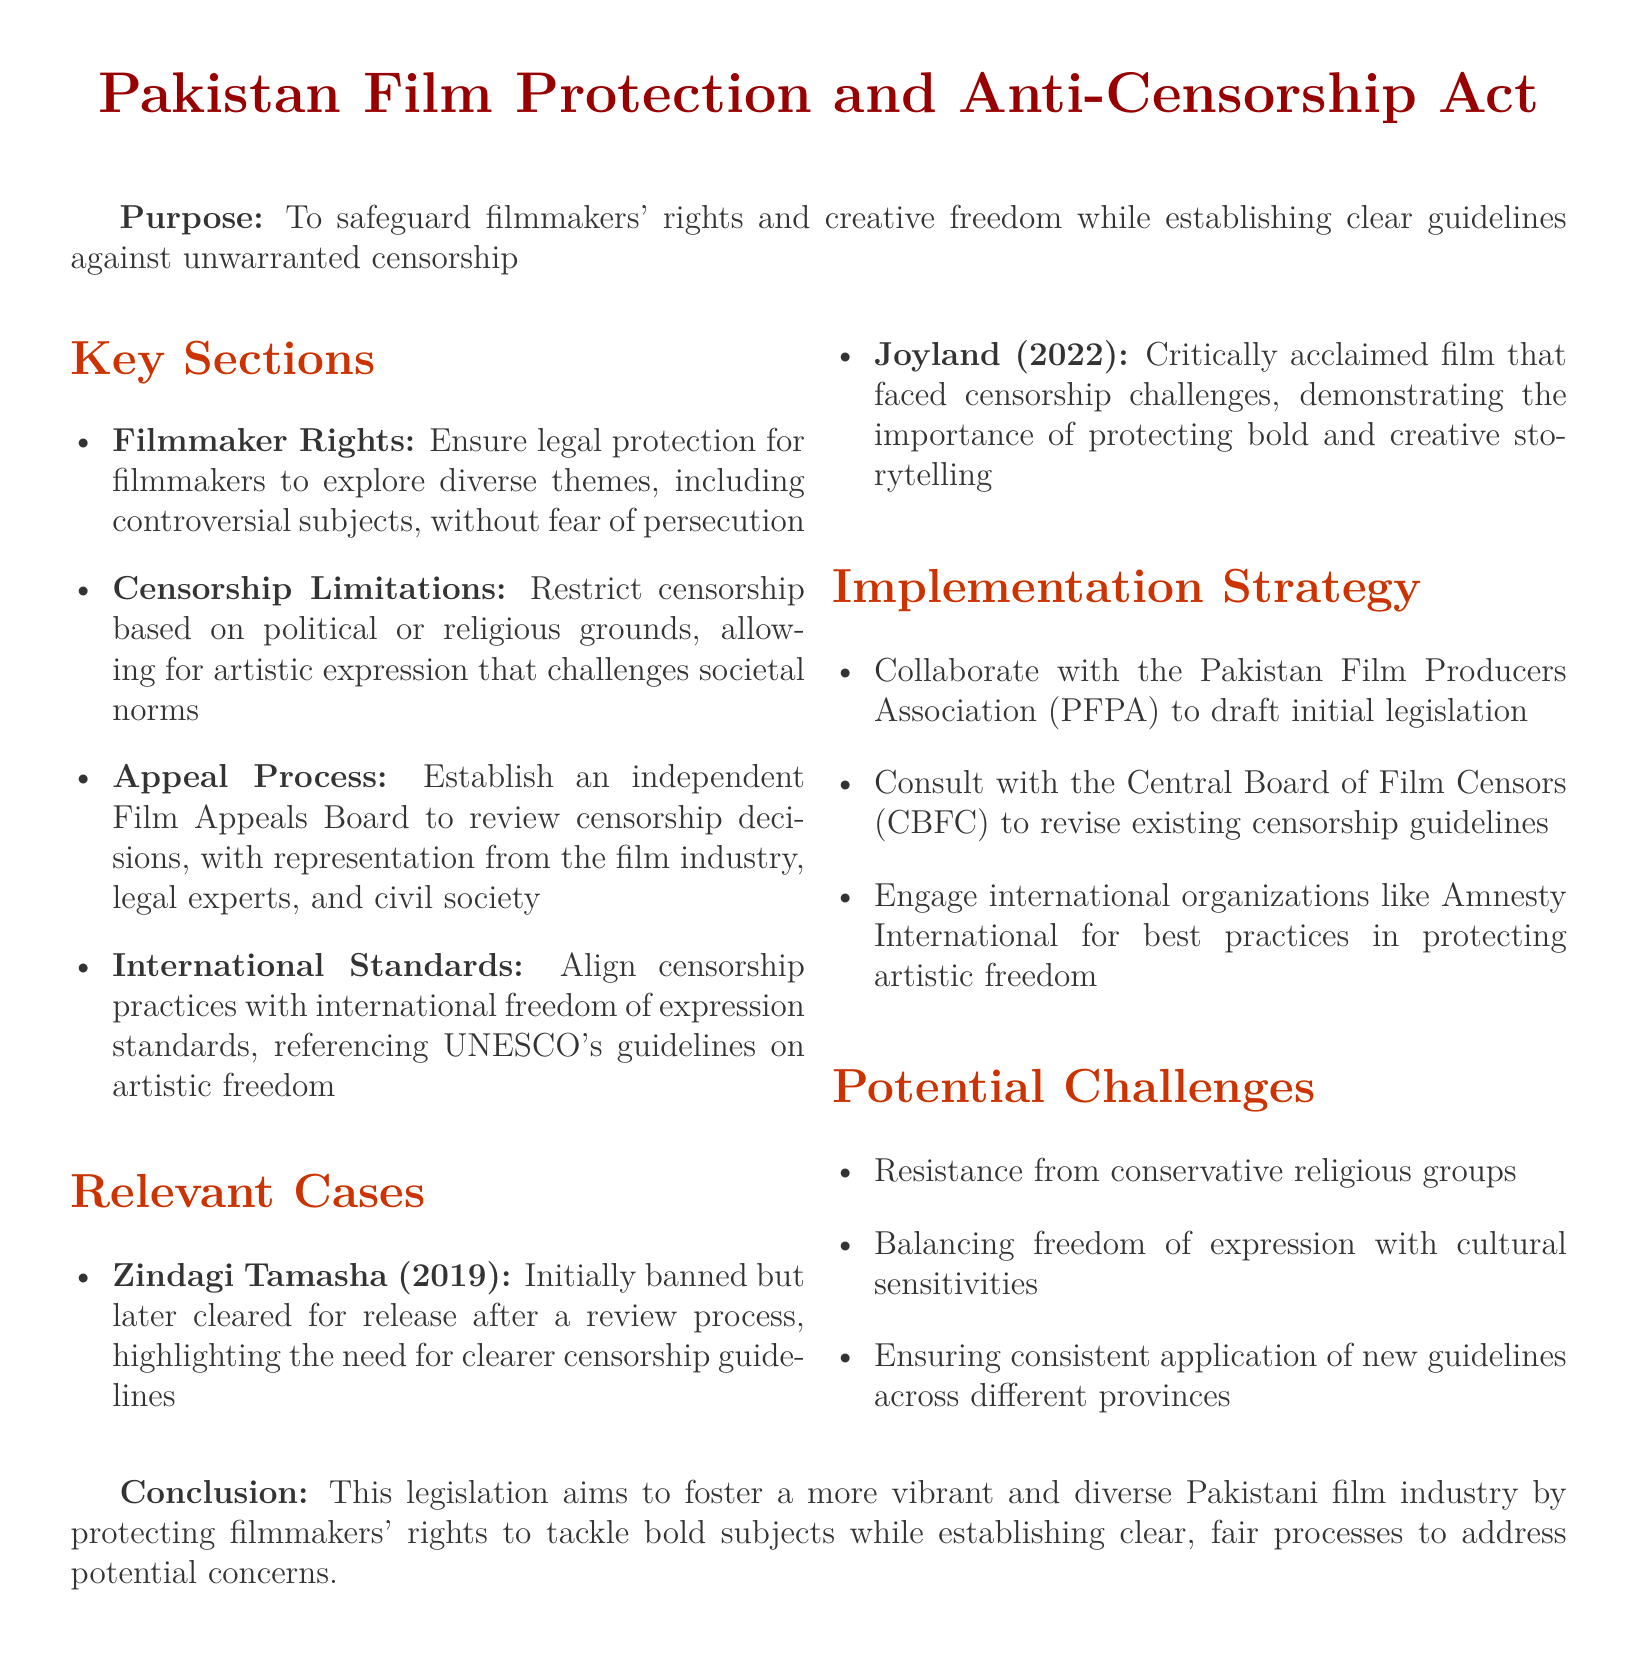What is the title of the legislation? The title of the legislation is found at the beginning of the document.
Answer: Pakistan Film Protection and Anti-Censorship Act What is the main purpose of the act? The purpose is mentioned in the second line of the document.
Answer: To safeguard filmmakers' rights and creative freedom while establishing clear guidelines against unwarranted censorship Who reviews censorship decisions according to the act? The document specifies the entity responsible for reviewing decisions.
Answer: Film Appeals Board Which film was banned initially but later cleared for release? This case is listed under the relevant cases section.
Answer: Zindagi Tamasha What year was Joyland released? The release year of Joyland is noted in the relevant cases section.
Answer: 2022 What body is consulted to revise existing censorship guidelines? The relevant strategy section identifies the organization involved.
Answer: Central Board of Film Censors Name one potential challenge mentioned in the document. The document lists possible challenges under potential challenges section.
Answer: Resistance from conservative religious groups What international organization is mentioned for best practices? This organization is referenced in the implementation strategy section.
Answer: Amnesty International 